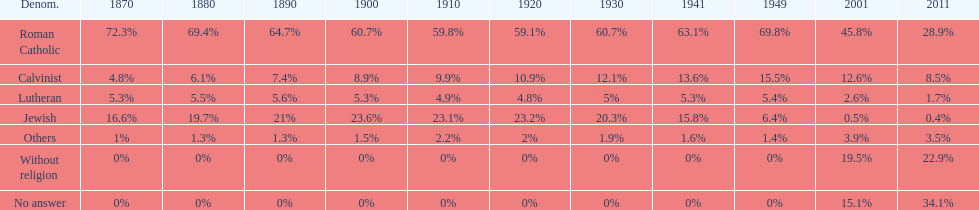Which denomination held the largest percentage in 1880? Roman Catholic. 